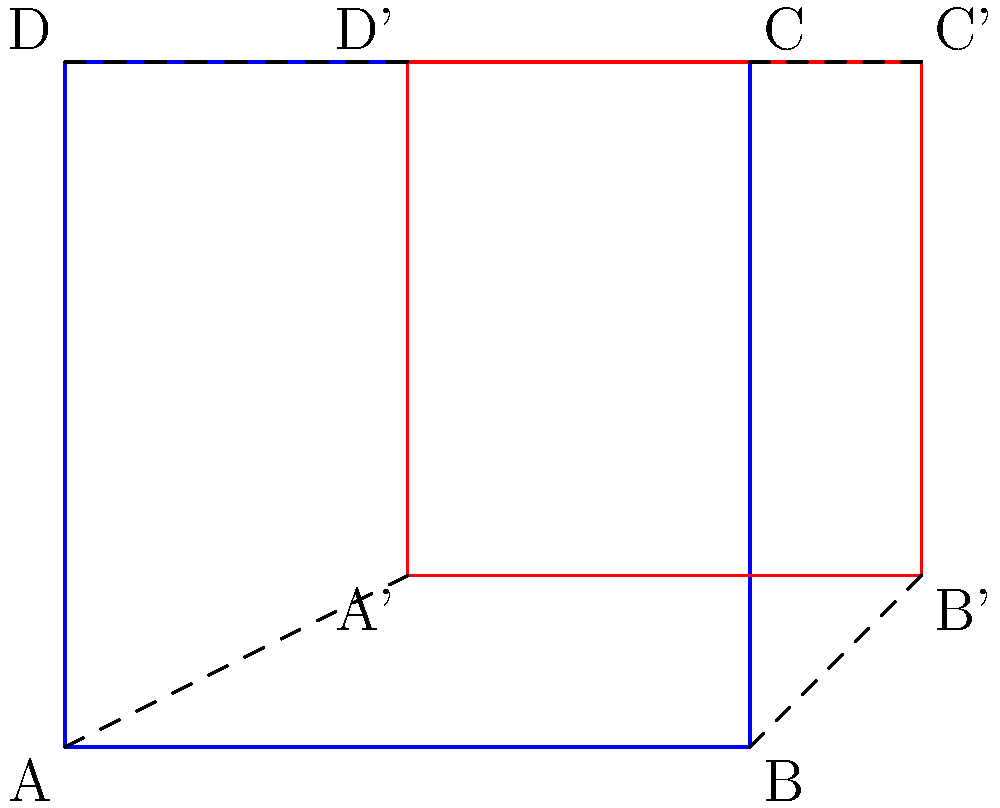As part of a town square redesign project, the original square ABCD is transformed into A'B'C'D'. If this transformation can be described as a composition of a translation and a dilation, what is the scale factor of the dilation and the translation vector? To solve this problem, we need to analyze the transformation step-by-step:

1. First, let's identify the changes in the square's dimensions:
   - Original width: $AB = 4$ units
   - New width: $A'B' = 3$ units
   - Original height: $AD = 4$ units
   - New height: $A'D' = 3$ units

2. The scale factor of the dilation can be calculated by dividing the new dimension by the original dimension:
   Scale factor = $\frac{A'B'}{AB} = \frac{3}{4} = 0.75$

3. To find the translation vector, we need to consider the movement of a point after dilation:
   - Point A would be at $(0 * 0.75, 0 * 0.75) = (0, 0)$ after dilation
   - A' is at $(2, 1)$

4. The translation vector is the difference between these points:
   Translation vector = $A' - A_{dilated} = (2, 1) - (0, 0) = (2, 1)$

5. To verify, we can check another point:
   - B would be at $(4 * 0.75, 0 * 0.75) = (3, 0)$ after dilation
   - Adding the translation vector: $(3, 0) + (2, 1) = (5, 1)$, which is indeed B'

Therefore, the transformation is a dilation with scale factor 0.75, followed by a translation of (2, 1).
Answer: Scale factor: 0.75; Translation vector: (2, 1) 